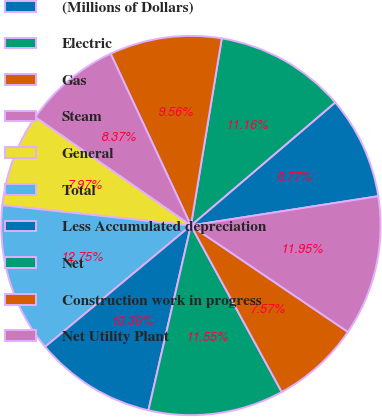Convert chart to OTSL. <chart><loc_0><loc_0><loc_500><loc_500><pie_chart><fcel>(Millions of Dollars)<fcel>Electric<fcel>Gas<fcel>Steam<fcel>General<fcel>Total<fcel>Less Accumulated depreciation<fcel>Net<fcel>Construction work in progress<fcel>Net Utility Plant<nl><fcel>8.77%<fcel>11.16%<fcel>9.56%<fcel>8.37%<fcel>7.97%<fcel>12.75%<fcel>10.36%<fcel>11.55%<fcel>7.57%<fcel>11.95%<nl></chart> 